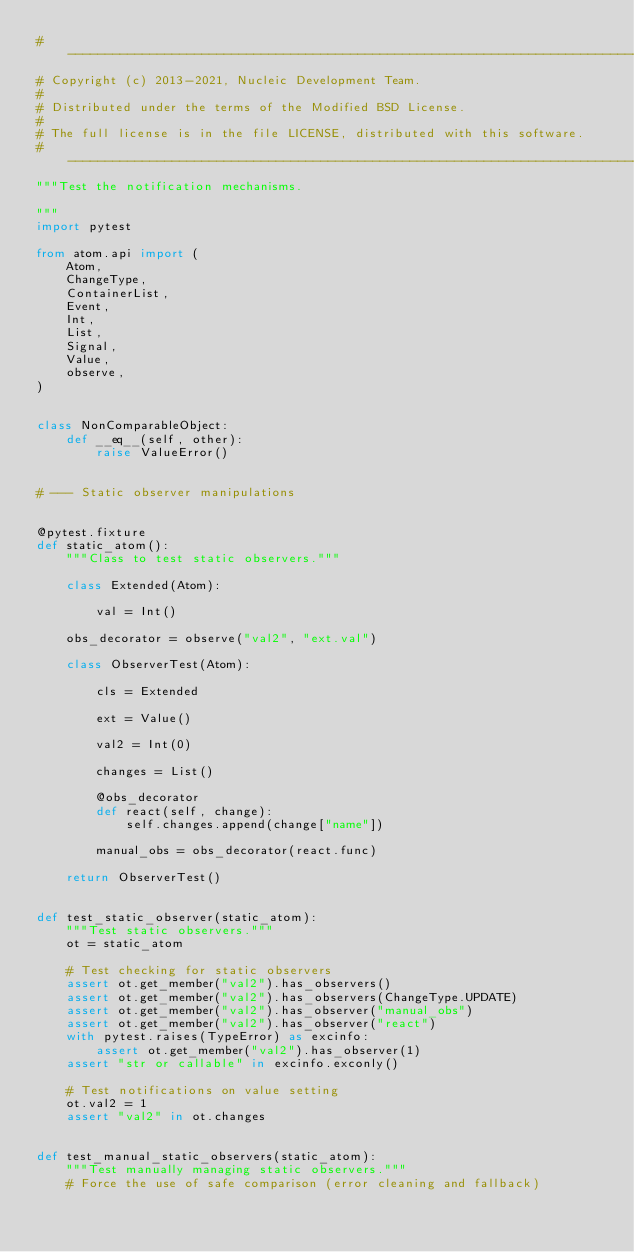Convert code to text. <code><loc_0><loc_0><loc_500><loc_500><_Python_># --------------------------------------------------------------------------------------
# Copyright (c) 2013-2021, Nucleic Development Team.
#
# Distributed under the terms of the Modified BSD License.
#
# The full license is in the file LICENSE, distributed with this software.
# --------------------------------------------------------------------------------------
"""Test the notification mechanisms.

"""
import pytest

from atom.api import (
    Atom,
    ChangeType,
    ContainerList,
    Event,
    Int,
    List,
    Signal,
    Value,
    observe,
)


class NonComparableObject:
    def __eq__(self, other):
        raise ValueError()


# --- Static observer manipulations


@pytest.fixture
def static_atom():
    """Class to test static observers."""

    class Extended(Atom):

        val = Int()

    obs_decorator = observe("val2", "ext.val")

    class ObserverTest(Atom):

        cls = Extended

        ext = Value()

        val2 = Int(0)

        changes = List()

        @obs_decorator
        def react(self, change):
            self.changes.append(change["name"])

        manual_obs = obs_decorator(react.func)

    return ObserverTest()


def test_static_observer(static_atom):
    """Test static observers."""
    ot = static_atom

    # Test checking for static observers
    assert ot.get_member("val2").has_observers()
    assert ot.get_member("val2").has_observers(ChangeType.UPDATE)
    assert ot.get_member("val2").has_observer("manual_obs")
    assert ot.get_member("val2").has_observer("react")
    with pytest.raises(TypeError) as excinfo:
        assert ot.get_member("val2").has_observer(1)
    assert "str or callable" in excinfo.exconly()

    # Test notifications on value setting
    ot.val2 = 1
    assert "val2" in ot.changes


def test_manual_static_observers(static_atom):
    """Test manually managing static observers."""
    # Force the use of safe comparison (error cleaning and fallback)</code> 